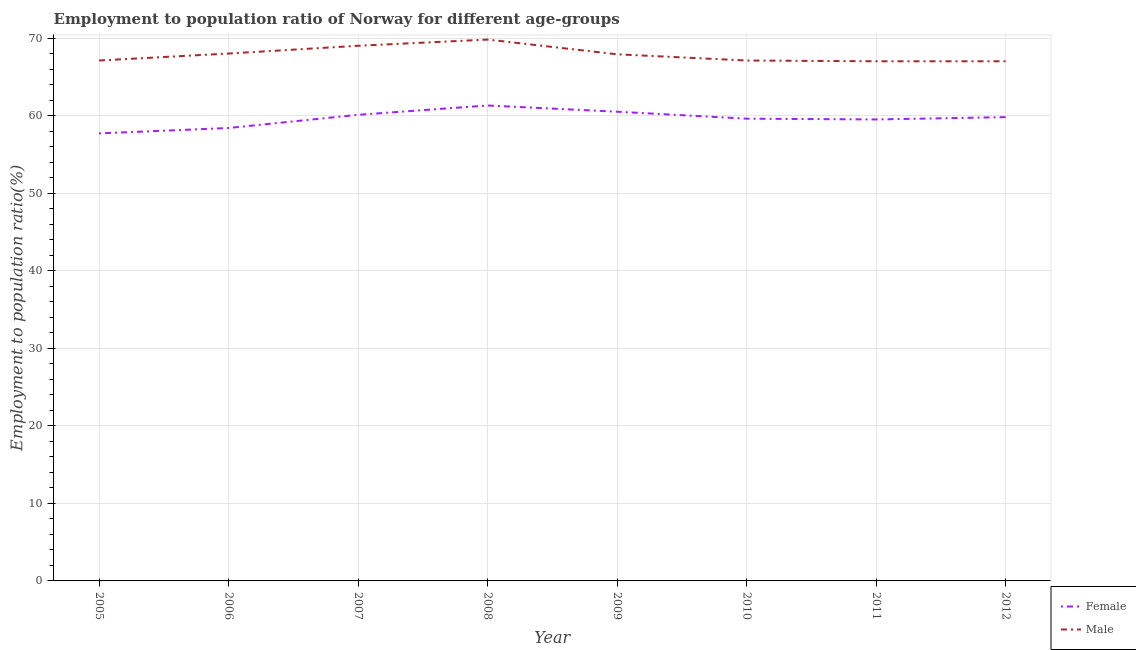How many different coloured lines are there?
Make the answer very short. 2. Does the line corresponding to employment to population ratio(female) intersect with the line corresponding to employment to population ratio(male)?
Your response must be concise. No. Is the number of lines equal to the number of legend labels?
Offer a very short reply. Yes. What is the employment to population ratio(male) in 2008?
Your answer should be compact. 69.8. Across all years, what is the maximum employment to population ratio(male)?
Ensure brevity in your answer.  69.8. What is the total employment to population ratio(female) in the graph?
Offer a very short reply. 476.9. What is the difference between the employment to population ratio(female) in 2005 and that in 2007?
Ensure brevity in your answer.  -2.4. What is the difference between the employment to population ratio(male) in 2009 and the employment to population ratio(female) in 2010?
Your response must be concise. 8.3. What is the average employment to population ratio(male) per year?
Your answer should be compact. 67.86. In the year 2007, what is the difference between the employment to population ratio(male) and employment to population ratio(female)?
Ensure brevity in your answer.  8.9. In how many years, is the employment to population ratio(male) greater than 34 %?
Keep it short and to the point. 8. What is the ratio of the employment to population ratio(female) in 2008 to that in 2011?
Your answer should be compact. 1.03. Is the difference between the employment to population ratio(female) in 2006 and 2011 greater than the difference between the employment to population ratio(male) in 2006 and 2011?
Your answer should be compact. No. What is the difference between the highest and the second highest employment to population ratio(male)?
Make the answer very short. 0.8. What is the difference between the highest and the lowest employment to population ratio(female)?
Ensure brevity in your answer.  3.6. In how many years, is the employment to population ratio(female) greater than the average employment to population ratio(female) taken over all years?
Make the answer very short. 4. Is the sum of the employment to population ratio(female) in 2007 and 2010 greater than the maximum employment to population ratio(male) across all years?
Provide a short and direct response. Yes. Does the employment to population ratio(male) monotonically increase over the years?
Your response must be concise. No. Is the employment to population ratio(male) strictly greater than the employment to population ratio(female) over the years?
Make the answer very short. Yes. Is the employment to population ratio(male) strictly less than the employment to population ratio(female) over the years?
Offer a very short reply. No. How many lines are there?
Your answer should be very brief. 2. What is the difference between two consecutive major ticks on the Y-axis?
Ensure brevity in your answer.  10. Does the graph contain grids?
Your response must be concise. Yes. Where does the legend appear in the graph?
Give a very brief answer. Bottom right. What is the title of the graph?
Provide a succinct answer. Employment to population ratio of Norway for different age-groups. Does "Public credit registry" appear as one of the legend labels in the graph?
Make the answer very short. No. What is the label or title of the X-axis?
Offer a very short reply. Year. What is the label or title of the Y-axis?
Ensure brevity in your answer.  Employment to population ratio(%). What is the Employment to population ratio(%) of Female in 2005?
Ensure brevity in your answer.  57.7. What is the Employment to population ratio(%) in Male in 2005?
Your answer should be compact. 67.1. What is the Employment to population ratio(%) in Female in 2006?
Keep it short and to the point. 58.4. What is the Employment to population ratio(%) of Female in 2007?
Provide a succinct answer. 60.1. What is the Employment to population ratio(%) of Female in 2008?
Offer a terse response. 61.3. What is the Employment to population ratio(%) in Male in 2008?
Make the answer very short. 69.8. What is the Employment to population ratio(%) of Female in 2009?
Ensure brevity in your answer.  60.5. What is the Employment to population ratio(%) of Male in 2009?
Offer a terse response. 67.9. What is the Employment to population ratio(%) in Female in 2010?
Your response must be concise. 59.6. What is the Employment to population ratio(%) of Male in 2010?
Your answer should be compact. 67.1. What is the Employment to population ratio(%) of Female in 2011?
Offer a very short reply. 59.5. What is the Employment to population ratio(%) of Female in 2012?
Keep it short and to the point. 59.8. What is the Employment to population ratio(%) in Male in 2012?
Give a very brief answer. 67. Across all years, what is the maximum Employment to population ratio(%) of Female?
Ensure brevity in your answer.  61.3. Across all years, what is the maximum Employment to population ratio(%) of Male?
Keep it short and to the point. 69.8. Across all years, what is the minimum Employment to population ratio(%) in Female?
Your answer should be very brief. 57.7. Across all years, what is the minimum Employment to population ratio(%) of Male?
Offer a very short reply. 67. What is the total Employment to population ratio(%) in Female in the graph?
Offer a terse response. 476.9. What is the total Employment to population ratio(%) of Male in the graph?
Offer a terse response. 542.9. What is the difference between the Employment to population ratio(%) of Female in 2005 and that in 2006?
Your answer should be very brief. -0.7. What is the difference between the Employment to population ratio(%) in Male in 2005 and that in 2006?
Provide a short and direct response. -0.9. What is the difference between the Employment to population ratio(%) in Female in 2005 and that in 2007?
Your answer should be compact. -2.4. What is the difference between the Employment to population ratio(%) in Male in 2005 and that in 2007?
Make the answer very short. -1.9. What is the difference between the Employment to population ratio(%) in Male in 2005 and that in 2008?
Keep it short and to the point. -2.7. What is the difference between the Employment to population ratio(%) in Male in 2005 and that in 2009?
Ensure brevity in your answer.  -0.8. What is the difference between the Employment to population ratio(%) of Female in 2005 and that in 2010?
Your answer should be compact. -1.9. What is the difference between the Employment to population ratio(%) in Female in 2005 and that in 2011?
Your answer should be compact. -1.8. What is the difference between the Employment to population ratio(%) in Male in 2005 and that in 2011?
Offer a terse response. 0.1. What is the difference between the Employment to population ratio(%) of Male in 2005 and that in 2012?
Ensure brevity in your answer.  0.1. What is the difference between the Employment to population ratio(%) of Male in 2006 and that in 2007?
Your response must be concise. -1. What is the difference between the Employment to population ratio(%) in Female in 2006 and that in 2008?
Offer a very short reply. -2.9. What is the difference between the Employment to population ratio(%) of Male in 2006 and that in 2008?
Give a very brief answer. -1.8. What is the difference between the Employment to population ratio(%) of Female in 2006 and that in 2009?
Ensure brevity in your answer.  -2.1. What is the difference between the Employment to population ratio(%) of Male in 2006 and that in 2010?
Make the answer very short. 0.9. What is the difference between the Employment to population ratio(%) in Female in 2006 and that in 2012?
Provide a succinct answer. -1.4. What is the difference between the Employment to population ratio(%) of Male in 2006 and that in 2012?
Provide a succinct answer. 1. What is the difference between the Employment to population ratio(%) of Male in 2007 and that in 2008?
Provide a succinct answer. -0.8. What is the difference between the Employment to population ratio(%) in Female in 2007 and that in 2009?
Your response must be concise. -0.4. What is the difference between the Employment to population ratio(%) of Female in 2007 and that in 2011?
Provide a succinct answer. 0.6. What is the difference between the Employment to population ratio(%) of Male in 2007 and that in 2011?
Give a very brief answer. 2. What is the difference between the Employment to population ratio(%) in Female in 2007 and that in 2012?
Offer a very short reply. 0.3. What is the difference between the Employment to population ratio(%) in Male in 2007 and that in 2012?
Offer a terse response. 2. What is the difference between the Employment to population ratio(%) in Male in 2008 and that in 2009?
Provide a short and direct response. 1.9. What is the difference between the Employment to population ratio(%) of Female in 2008 and that in 2010?
Your answer should be compact. 1.7. What is the difference between the Employment to population ratio(%) in Female in 2008 and that in 2011?
Offer a very short reply. 1.8. What is the difference between the Employment to population ratio(%) of Female in 2008 and that in 2012?
Your response must be concise. 1.5. What is the difference between the Employment to population ratio(%) of Male in 2008 and that in 2012?
Give a very brief answer. 2.8. What is the difference between the Employment to population ratio(%) of Female in 2009 and that in 2010?
Your answer should be very brief. 0.9. What is the difference between the Employment to population ratio(%) of Female in 2009 and that in 2012?
Make the answer very short. 0.7. What is the difference between the Employment to population ratio(%) in Male in 2009 and that in 2012?
Your response must be concise. 0.9. What is the difference between the Employment to population ratio(%) of Female in 2010 and that in 2011?
Your answer should be compact. 0.1. What is the difference between the Employment to population ratio(%) in Male in 2010 and that in 2011?
Give a very brief answer. 0.1. What is the difference between the Employment to population ratio(%) of Female in 2005 and the Employment to population ratio(%) of Male in 2006?
Give a very brief answer. -10.3. What is the difference between the Employment to population ratio(%) in Female in 2005 and the Employment to population ratio(%) in Male in 2007?
Your answer should be very brief. -11.3. What is the difference between the Employment to population ratio(%) of Female in 2005 and the Employment to population ratio(%) of Male in 2012?
Provide a succinct answer. -9.3. What is the difference between the Employment to population ratio(%) of Female in 2006 and the Employment to population ratio(%) of Male in 2007?
Your answer should be compact. -10.6. What is the difference between the Employment to population ratio(%) in Female in 2006 and the Employment to population ratio(%) in Male in 2011?
Provide a succinct answer. -8.6. What is the difference between the Employment to population ratio(%) of Female in 2006 and the Employment to population ratio(%) of Male in 2012?
Offer a terse response. -8.6. What is the difference between the Employment to population ratio(%) of Female in 2007 and the Employment to population ratio(%) of Male in 2011?
Your answer should be very brief. -6.9. What is the difference between the Employment to population ratio(%) of Female in 2007 and the Employment to population ratio(%) of Male in 2012?
Provide a succinct answer. -6.9. What is the difference between the Employment to population ratio(%) in Female in 2008 and the Employment to population ratio(%) in Male in 2011?
Your response must be concise. -5.7. What is the difference between the Employment to population ratio(%) of Female in 2009 and the Employment to population ratio(%) of Male in 2010?
Your response must be concise. -6.6. What is the difference between the Employment to population ratio(%) of Female in 2010 and the Employment to population ratio(%) of Male in 2012?
Ensure brevity in your answer.  -7.4. What is the average Employment to population ratio(%) of Female per year?
Ensure brevity in your answer.  59.61. What is the average Employment to population ratio(%) of Male per year?
Your answer should be very brief. 67.86. In the year 2006, what is the difference between the Employment to population ratio(%) in Female and Employment to population ratio(%) in Male?
Your response must be concise. -9.6. In the year 2007, what is the difference between the Employment to population ratio(%) of Female and Employment to population ratio(%) of Male?
Provide a short and direct response. -8.9. In the year 2009, what is the difference between the Employment to population ratio(%) in Female and Employment to population ratio(%) in Male?
Your response must be concise. -7.4. In the year 2012, what is the difference between the Employment to population ratio(%) in Female and Employment to population ratio(%) in Male?
Give a very brief answer. -7.2. What is the ratio of the Employment to population ratio(%) of Female in 2005 to that in 2006?
Ensure brevity in your answer.  0.99. What is the ratio of the Employment to population ratio(%) of Female in 2005 to that in 2007?
Ensure brevity in your answer.  0.96. What is the ratio of the Employment to population ratio(%) in Male in 2005 to that in 2007?
Provide a short and direct response. 0.97. What is the ratio of the Employment to population ratio(%) of Female in 2005 to that in 2008?
Give a very brief answer. 0.94. What is the ratio of the Employment to population ratio(%) in Male in 2005 to that in 2008?
Provide a short and direct response. 0.96. What is the ratio of the Employment to population ratio(%) of Female in 2005 to that in 2009?
Your response must be concise. 0.95. What is the ratio of the Employment to population ratio(%) of Female in 2005 to that in 2010?
Provide a succinct answer. 0.97. What is the ratio of the Employment to population ratio(%) of Female in 2005 to that in 2011?
Provide a succinct answer. 0.97. What is the ratio of the Employment to population ratio(%) of Female in 2005 to that in 2012?
Offer a very short reply. 0.96. What is the ratio of the Employment to population ratio(%) in Male in 2005 to that in 2012?
Ensure brevity in your answer.  1. What is the ratio of the Employment to population ratio(%) of Female in 2006 to that in 2007?
Your answer should be compact. 0.97. What is the ratio of the Employment to population ratio(%) of Male in 2006 to that in 2007?
Keep it short and to the point. 0.99. What is the ratio of the Employment to population ratio(%) in Female in 2006 to that in 2008?
Your response must be concise. 0.95. What is the ratio of the Employment to population ratio(%) of Male in 2006 to that in 2008?
Your response must be concise. 0.97. What is the ratio of the Employment to population ratio(%) of Female in 2006 to that in 2009?
Keep it short and to the point. 0.97. What is the ratio of the Employment to population ratio(%) of Male in 2006 to that in 2009?
Your answer should be very brief. 1. What is the ratio of the Employment to population ratio(%) in Female in 2006 to that in 2010?
Your answer should be compact. 0.98. What is the ratio of the Employment to population ratio(%) in Male in 2006 to that in 2010?
Provide a short and direct response. 1.01. What is the ratio of the Employment to population ratio(%) of Female in 2006 to that in 2011?
Provide a short and direct response. 0.98. What is the ratio of the Employment to population ratio(%) in Male in 2006 to that in 2011?
Your answer should be compact. 1.01. What is the ratio of the Employment to population ratio(%) in Female in 2006 to that in 2012?
Provide a short and direct response. 0.98. What is the ratio of the Employment to population ratio(%) in Male in 2006 to that in 2012?
Give a very brief answer. 1.01. What is the ratio of the Employment to population ratio(%) in Female in 2007 to that in 2008?
Ensure brevity in your answer.  0.98. What is the ratio of the Employment to population ratio(%) in Male in 2007 to that in 2008?
Your response must be concise. 0.99. What is the ratio of the Employment to population ratio(%) in Female in 2007 to that in 2009?
Provide a succinct answer. 0.99. What is the ratio of the Employment to population ratio(%) in Male in 2007 to that in 2009?
Make the answer very short. 1.02. What is the ratio of the Employment to population ratio(%) in Female in 2007 to that in 2010?
Your response must be concise. 1.01. What is the ratio of the Employment to population ratio(%) of Male in 2007 to that in 2010?
Provide a succinct answer. 1.03. What is the ratio of the Employment to population ratio(%) in Female in 2007 to that in 2011?
Your response must be concise. 1.01. What is the ratio of the Employment to population ratio(%) in Male in 2007 to that in 2011?
Offer a terse response. 1.03. What is the ratio of the Employment to population ratio(%) of Female in 2007 to that in 2012?
Keep it short and to the point. 1. What is the ratio of the Employment to population ratio(%) of Male in 2007 to that in 2012?
Ensure brevity in your answer.  1.03. What is the ratio of the Employment to population ratio(%) in Female in 2008 to that in 2009?
Offer a very short reply. 1.01. What is the ratio of the Employment to population ratio(%) in Male in 2008 to that in 2009?
Your answer should be very brief. 1.03. What is the ratio of the Employment to population ratio(%) in Female in 2008 to that in 2010?
Your answer should be compact. 1.03. What is the ratio of the Employment to population ratio(%) of Male in 2008 to that in 2010?
Keep it short and to the point. 1.04. What is the ratio of the Employment to population ratio(%) of Female in 2008 to that in 2011?
Offer a very short reply. 1.03. What is the ratio of the Employment to population ratio(%) of Male in 2008 to that in 2011?
Offer a very short reply. 1.04. What is the ratio of the Employment to population ratio(%) in Female in 2008 to that in 2012?
Keep it short and to the point. 1.03. What is the ratio of the Employment to population ratio(%) in Male in 2008 to that in 2012?
Your response must be concise. 1.04. What is the ratio of the Employment to population ratio(%) in Female in 2009 to that in 2010?
Your response must be concise. 1.02. What is the ratio of the Employment to population ratio(%) in Male in 2009 to that in 2010?
Your answer should be very brief. 1.01. What is the ratio of the Employment to population ratio(%) in Female in 2009 to that in 2011?
Keep it short and to the point. 1.02. What is the ratio of the Employment to population ratio(%) of Male in 2009 to that in 2011?
Your response must be concise. 1.01. What is the ratio of the Employment to population ratio(%) of Female in 2009 to that in 2012?
Give a very brief answer. 1.01. What is the ratio of the Employment to population ratio(%) of Male in 2009 to that in 2012?
Offer a very short reply. 1.01. What is the ratio of the Employment to population ratio(%) in Male in 2010 to that in 2011?
Your answer should be compact. 1. What is the ratio of the Employment to population ratio(%) in Female in 2010 to that in 2012?
Make the answer very short. 1. What is the ratio of the Employment to population ratio(%) of Female in 2011 to that in 2012?
Your answer should be compact. 0.99. What is the ratio of the Employment to population ratio(%) in Male in 2011 to that in 2012?
Ensure brevity in your answer.  1. What is the difference between the highest and the second highest Employment to population ratio(%) in Female?
Keep it short and to the point. 0.8. What is the difference between the highest and the lowest Employment to population ratio(%) in Male?
Your answer should be very brief. 2.8. 